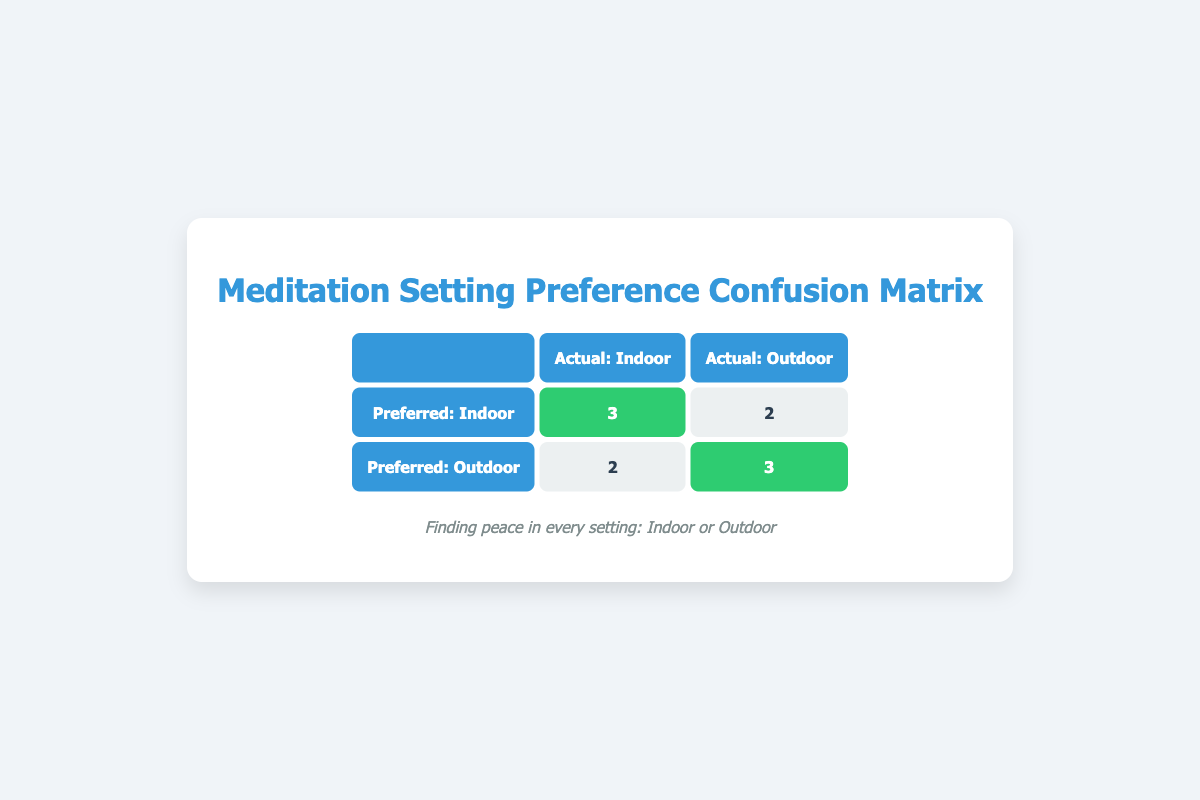What is the number of patients who preferred an indoor setting and actually experienced it? In the table, we look at the row for "Preferred: Indoor" and the column "Actual: Indoor." The number in this cell is 3, indicating that 3 patients preferred an indoor setting and experienced it.
Answer: 3 How many patients preferred an outdoor setting and actually experienced it? In the table, we refer to the row for "Preferred: Outdoor" and the column "Actual: Outdoor." The number present in this cell is 3, showing that 3 patients preferred an outdoor setting and had the same experience.
Answer: 3 What is the total number of patients surveyed? To find the total number of patients surveyed, we sum all unique entries from the "patient_id" field. There are 10 unique patient IDs, suggesting that 10 patients participated in the survey.
Answer: 10 What is the number of patients who had an outdoor experience but preferred an indoor setting? Here, we check the row for "Preferred: Indoor" and the column "Actual: Outdoor." The value in this cell is 2, meaning that 2 patients preferred an indoor setting but experienced an outdoor setting instead.
Answer: 2 Are there more patients who prefer an indoor setting than an outdoor one? We examine the preferences: The sum of patients preferring indoor (3 + 2 = 5) and outdoor (2 + 3 = 5) both total 5; hence, the counts are equal. Therefore, it is false that more patients prefer one over the other.
Answer: No What is the difference in the number of patients who preferred an indoor setting and those who preferred an outdoor setting? We calculate the total preferences: Indoor preference totals to 3 (Indoor-Indoor) + 2 (Indoor-Outdoor) = 5. For outdoor, it's 2 (Outdoor-Indoor) + 3 (Outdoor-Outdoor) = 5. The difference is 5 - 5 = 0.
Answer: 0 Among the patients who preferred an outdoor setting, how many did not experience the outdoor setting? We look at the row for "Preferred: Outdoor" and check for patients who had "Actual: Indoor," which is 2. Thus, 2 patients preferred the outdoor setting but did not experience it.
Answer: 2 Is it true that most patients prefer an indoor setting over outdoor? Considering preferences: Indoor totals 5 and Outdoor also totals 5. Since they are equal, it is not true that most patients prefer indoor over outdoor.
Answer: No What is the total count of patients who had an experience that matched their preference? This is obtained by adding the diagonal of the confusion matrix (Indoor-Indoor + Outdoor-Outdoor), which is 3 + 3 = 6 patients who had experiences that matched their preferences.
Answer: 6 